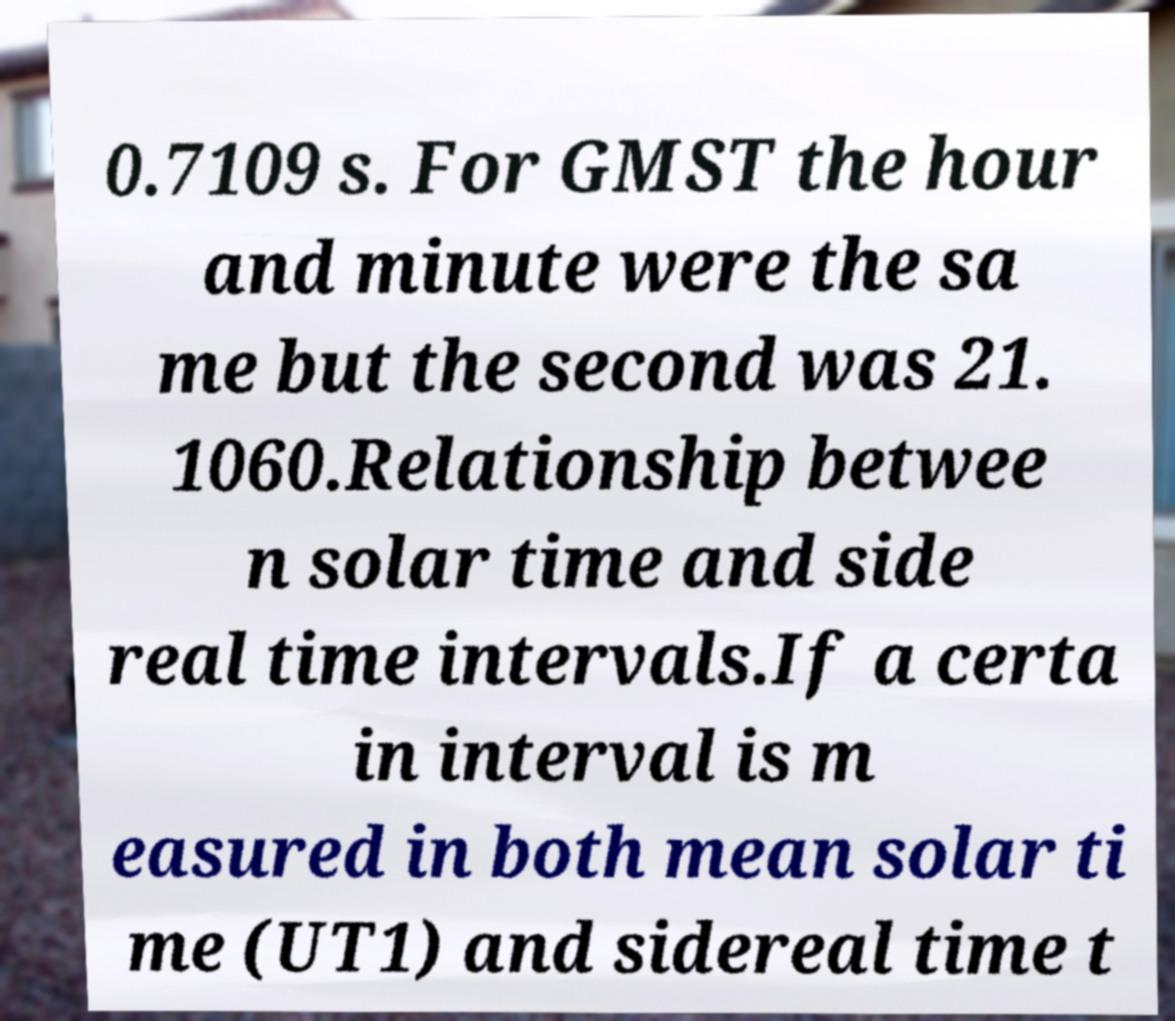Could you extract and type out the text from this image? 0.7109 s. For GMST the hour and minute were the sa me but the second was 21. 1060.Relationship betwee n solar time and side real time intervals.If a certa in interval is m easured in both mean solar ti me (UT1) and sidereal time t 